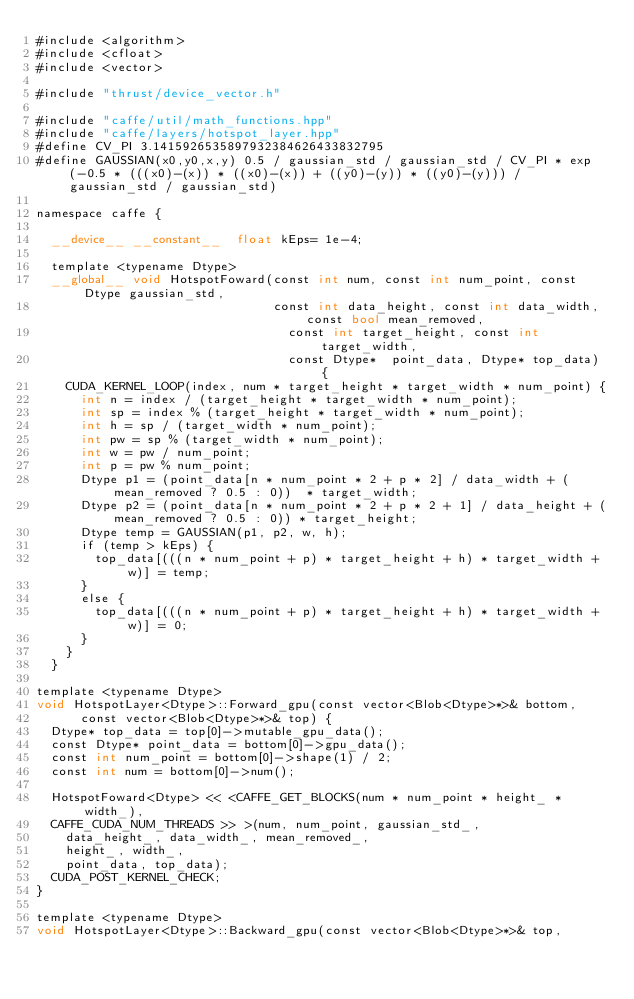Convert code to text. <code><loc_0><loc_0><loc_500><loc_500><_Cuda_>#include <algorithm>
#include <cfloat>
#include <vector>

#include "thrust/device_vector.h"

#include "caffe/util/math_functions.hpp"
#include "caffe/layers/hotspot_layer.hpp"
#define CV_PI 3.1415926535897932384626433832795
#define GAUSSIAN(x0,y0,x,y) 0.5 / gaussian_std / gaussian_std / CV_PI * exp(-0.5 * (((x0)-(x)) * ((x0)-(x)) + ((y0)-(y)) * ((y0)-(y))) / gaussian_std / gaussian_std)

namespace caffe {

  __device__ __constant__  float kEps= 1e-4;

  template <typename Dtype>
  __global__ void HotspotFoward(const int num, const int num_point, const Dtype gaussian_std,
                                const int data_height, const int data_width, const bool mean_removed,
                                  const int target_height, const int target_width,
                                  const Dtype*  point_data, Dtype* top_data) {
    CUDA_KERNEL_LOOP(index, num * target_height * target_width * num_point) {
      int n = index / (target_height * target_width * num_point);
      int sp = index % (target_height * target_width * num_point);
      int h = sp / (target_width * num_point);
      int pw = sp % (target_width * num_point);
      int w = pw / num_point;
      int p = pw % num_point;
      Dtype p1 = (point_data[n * num_point * 2 + p * 2] / data_width + (mean_removed ? 0.5 : 0))  * target_width;
      Dtype p2 = (point_data[n * num_point * 2 + p * 2 + 1] / data_height + (mean_removed ? 0.5 : 0)) * target_height;
      Dtype temp = GAUSSIAN(p1, p2, w, h);
      if (temp > kEps) {
        top_data[(((n * num_point + p) * target_height + h) * target_width + w)] = temp;
      }
      else {
        top_data[(((n * num_point + p) * target_height + h) * target_width + w)] = 0;
      }
    }
  }

template <typename Dtype>
void HotspotLayer<Dtype>::Forward_gpu(const vector<Blob<Dtype>*>& bottom,
      const vector<Blob<Dtype>*>& top) {
  Dtype* top_data = top[0]->mutable_gpu_data();
  const Dtype* point_data = bottom[0]->gpu_data();
  const int num_point = bottom[0]->shape(1) / 2;
  const int num = bottom[0]->num();

  HotspotFoward<Dtype> << <CAFFE_GET_BLOCKS(num * num_point * height_ * width_),
  CAFFE_CUDA_NUM_THREADS >> >(num, num_point, gaussian_std_,
    data_height_, data_width_, mean_removed_,
    height_, width_,
    point_data, top_data);
  CUDA_POST_KERNEL_CHECK;
}

template <typename Dtype>
void HotspotLayer<Dtype>::Backward_gpu(const vector<Blob<Dtype>*>& top,</code> 